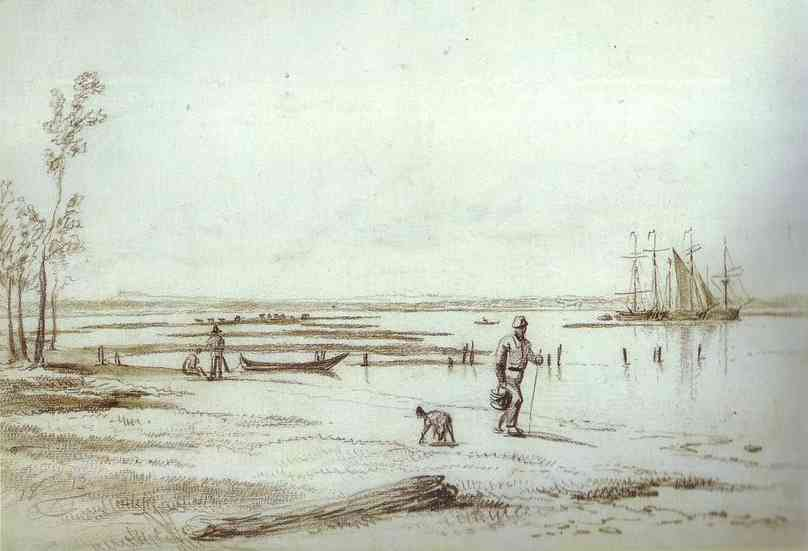Can you tell me more about the historical context of the scene depicted in this image? This image likely portrays a scene from the 17th or 18th century, judging by the style of the boat and the clothing of the man. During this period, such scenes were common in European riverine and coastal areas, which were hubs of transportation and trade. The sketch might be hinting at daily life near a bustling port or a quieter fishing village, reflecting the economic activities that were prevalent at the time. 